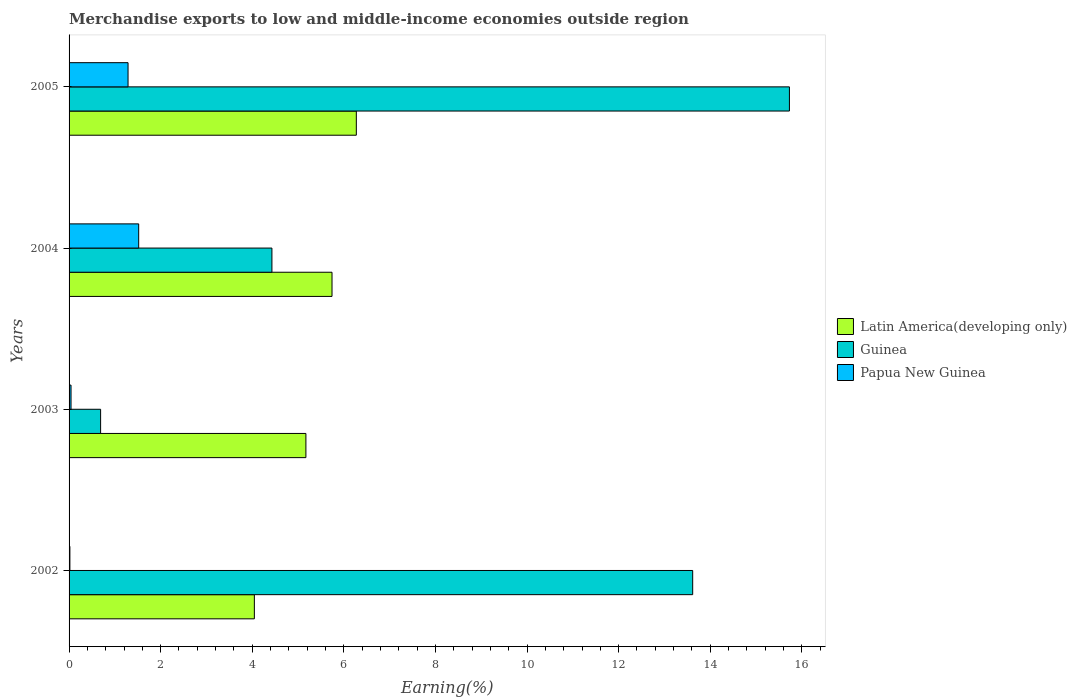How many different coloured bars are there?
Make the answer very short. 3. How many groups of bars are there?
Make the answer very short. 4. Are the number of bars per tick equal to the number of legend labels?
Your response must be concise. Yes. Are the number of bars on each tick of the Y-axis equal?
Your response must be concise. Yes. How many bars are there on the 1st tick from the top?
Your response must be concise. 3. How many bars are there on the 2nd tick from the bottom?
Provide a succinct answer. 3. What is the label of the 1st group of bars from the top?
Provide a short and direct response. 2005. In how many cases, is the number of bars for a given year not equal to the number of legend labels?
Your response must be concise. 0. What is the percentage of amount earned from merchandise exports in Guinea in 2002?
Provide a short and direct response. 13.62. Across all years, what is the maximum percentage of amount earned from merchandise exports in Papua New Guinea?
Keep it short and to the point. 1.52. Across all years, what is the minimum percentage of amount earned from merchandise exports in Latin America(developing only)?
Your answer should be compact. 4.05. In which year was the percentage of amount earned from merchandise exports in Latin America(developing only) minimum?
Make the answer very short. 2002. What is the total percentage of amount earned from merchandise exports in Guinea in the graph?
Provide a succinct answer. 34.46. What is the difference between the percentage of amount earned from merchandise exports in Guinea in 2002 and that in 2003?
Ensure brevity in your answer.  12.93. What is the difference between the percentage of amount earned from merchandise exports in Latin America(developing only) in 2004 and the percentage of amount earned from merchandise exports in Guinea in 2002?
Keep it short and to the point. -7.88. What is the average percentage of amount earned from merchandise exports in Papua New Guinea per year?
Make the answer very short. 0.72. In the year 2002, what is the difference between the percentage of amount earned from merchandise exports in Guinea and percentage of amount earned from merchandise exports in Latin America(developing only)?
Ensure brevity in your answer.  9.57. What is the ratio of the percentage of amount earned from merchandise exports in Latin America(developing only) in 2004 to that in 2005?
Offer a terse response. 0.92. Is the percentage of amount earned from merchandise exports in Guinea in 2003 less than that in 2005?
Give a very brief answer. Yes. What is the difference between the highest and the second highest percentage of amount earned from merchandise exports in Latin America(developing only)?
Offer a terse response. 0.53. What is the difference between the highest and the lowest percentage of amount earned from merchandise exports in Guinea?
Keep it short and to the point. 15.04. In how many years, is the percentage of amount earned from merchandise exports in Latin America(developing only) greater than the average percentage of amount earned from merchandise exports in Latin America(developing only) taken over all years?
Offer a terse response. 2. Is the sum of the percentage of amount earned from merchandise exports in Guinea in 2004 and 2005 greater than the maximum percentage of amount earned from merchandise exports in Latin America(developing only) across all years?
Keep it short and to the point. Yes. What does the 2nd bar from the top in 2004 represents?
Your response must be concise. Guinea. What does the 3rd bar from the bottom in 2004 represents?
Provide a short and direct response. Papua New Guinea. How many bars are there?
Your answer should be compact. 12. How are the legend labels stacked?
Ensure brevity in your answer.  Vertical. What is the title of the graph?
Your response must be concise. Merchandise exports to low and middle-income economies outside region. What is the label or title of the X-axis?
Give a very brief answer. Earning(%). What is the label or title of the Y-axis?
Your answer should be compact. Years. What is the Earning(%) in Latin America(developing only) in 2002?
Give a very brief answer. 4.05. What is the Earning(%) in Guinea in 2002?
Offer a terse response. 13.62. What is the Earning(%) in Papua New Guinea in 2002?
Ensure brevity in your answer.  0.02. What is the Earning(%) of Latin America(developing only) in 2003?
Make the answer very short. 5.17. What is the Earning(%) in Guinea in 2003?
Provide a short and direct response. 0.69. What is the Earning(%) in Papua New Guinea in 2003?
Offer a terse response. 0.04. What is the Earning(%) of Latin America(developing only) in 2004?
Offer a very short reply. 5.74. What is the Earning(%) in Guinea in 2004?
Keep it short and to the point. 4.43. What is the Earning(%) of Papua New Guinea in 2004?
Make the answer very short. 1.52. What is the Earning(%) of Latin America(developing only) in 2005?
Your answer should be compact. 6.27. What is the Earning(%) in Guinea in 2005?
Provide a succinct answer. 15.73. What is the Earning(%) in Papua New Guinea in 2005?
Provide a short and direct response. 1.29. Across all years, what is the maximum Earning(%) of Latin America(developing only)?
Provide a short and direct response. 6.27. Across all years, what is the maximum Earning(%) of Guinea?
Provide a short and direct response. 15.73. Across all years, what is the maximum Earning(%) of Papua New Guinea?
Offer a very short reply. 1.52. Across all years, what is the minimum Earning(%) in Latin America(developing only)?
Your answer should be compact. 4.05. Across all years, what is the minimum Earning(%) of Guinea?
Your answer should be compact. 0.69. Across all years, what is the minimum Earning(%) in Papua New Guinea?
Make the answer very short. 0.02. What is the total Earning(%) in Latin America(developing only) in the graph?
Make the answer very short. 21.23. What is the total Earning(%) of Guinea in the graph?
Keep it short and to the point. 34.46. What is the total Earning(%) of Papua New Guinea in the graph?
Your answer should be very brief. 2.87. What is the difference between the Earning(%) of Latin America(developing only) in 2002 and that in 2003?
Your answer should be very brief. -1.13. What is the difference between the Earning(%) in Guinea in 2002 and that in 2003?
Ensure brevity in your answer.  12.93. What is the difference between the Earning(%) of Papua New Guinea in 2002 and that in 2003?
Provide a succinct answer. -0.02. What is the difference between the Earning(%) in Latin America(developing only) in 2002 and that in 2004?
Provide a short and direct response. -1.7. What is the difference between the Earning(%) of Guinea in 2002 and that in 2004?
Keep it short and to the point. 9.19. What is the difference between the Earning(%) in Papua New Guinea in 2002 and that in 2004?
Provide a short and direct response. -1.5. What is the difference between the Earning(%) in Latin America(developing only) in 2002 and that in 2005?
Ensure brevity in your answer.  -2.23. What is the difference between the Earning(%) in Guinea in 2002 and that in 2005?
Offer a very short reply. -2.11. What is the difference between the Earning(%) of Papua New Guinea in 2002 and that in 2005?
Offer a very short reply. -1.27. What is the difference between the Earning(%) of Latin America(developing only) in 2003 and that in 2004?
Give a very brief answer. -0.57. What is the difference between the Earning(%) in Guinea in 2003 and that in 2004?
Provide a short and direct response. -3.74. What is the difference between the Earning(%) in Papua New Guinea in 2003 and that in 2004?
Give a very brief answer. -1.48. What is the difference between the Earning(%) of Latin America(developing only) in 2003 and that in 2005?
Make the answer very short. -1.1. What is the difference between the Earning(%) of Guinea in 2003 and that in 2005?
Provide a short and direct response. -15.04. What is the difference between the Earning(%) in Papua New Guinea in 2003 and that in 2005?
Your answer should be very brief. -1.25. What is the difference between the Earning(%) in Latin America(developing only) in 2004 and that in 2005?
Provide a succinct answer. -0.53. What is the difference between the Earning(%) in Guinea in 2004 and that in 2005?
Ensure brevity in your answer.  -11.3. What is the difference between the Earning(%) of Papua New Guinea in 2004 and that in 2005?
Give a very brief answer. 0.23. What is the difference between the Earning(%) in Latin America(developing only) in 2002 and the Earning(%) in Guinea in 2003?
Keep it short and to the point. 3.36. What is the difference between the Earning(%) in Latin America(developing only) in 2002 and the Earning(%) in Papua New Guinea in 2003?
Ensure brevity in your answer.  4. What is the difference between the Earning(%) in Guinea in 2002 and the Earning(%) in Papua New Guinea in 2003?
Provide a succinct answer. 13.57. What is the difference between the Earning(%) of Latin America(developing only) in 2002 and the Earning(%) of Guinea in 2004?
Provide a succinct answer. -0.38. What is the difference between the Earning(%) in Latin America(developing only) in 2002 and the Earning(%) in Papua New Guinea in 2004?
Your answer should be very brief. 2.53. What is the difference between the Earning(%) of Guinea in 2002 and the Earning(%) of Papua New Guinea in 2004?
Offer a terse response. 12.1. What is the difference between the Earning(%) of Latin America(developing only) in 2002 and the Earning(%) of Guinea in 2005?
Offer a very short reply. -11.68. What is the difference between the Earning(%) in Latin America(developing only) in 2002 and the Earning(%) in Papua New Guinea in 2005?
Offer a terse response. 2.76. What is the difference between the Earning(%) of Guinea in 2002 and the Earning(%) of Papua New Guinea in 2005?
Offer a very short reply. 12.33. What is the difference between the Earning(%) of Latin America(developing only) in 2003 and the Earning(%) of Guinea in 2004?
Keep it short and to the point. 0.74. What is the difference between the Earning(%) of Latin America(developing only) in 2003 and the Earning(%) of Papua New Guinea in 2004?
Ensure brevity in your answer.  3.65. What is the difference between the Earning(%) in Guinea in 2003 and the Earning(%) in Papua New Guinea in 2004?
Give a very brief answer. -0.83. What is the difference between the Earning(%) of Latin America(developing only) in 2003 and the Earning(%) of Guinea in 2005?
Your answer should be compact. -10.56. What is the difference between the Earning(%) in Latin America(developing only) in 2003 and the Earning(%) in Papua New Guinea in 2005?
Make the answer very short. 3.88. What is the difference between the Earning(%) of Guinea in 2003 and the Earning(%) of Papua New Guinea in 2005?
Your response must be concise. -0.6. What is the difference between the Earning(%) in Latin America(developing only) in 2004 and the Earning(%) in Guinea in 2005?
Ensure brevity in your answer.  -9.99. What is the difference between the Earning(%) in Latin America(developing only) in 2004 and the Earning(%) in Papua New Guinea in 2005?
Ensure brevity in your answer.  4.45. What is the difference between the Earning(%) in Guinea in 2004 and the Earning(%) in Papua New Guinea in 2005?
Provide a short and direct response. 3.14. What is the average Earning(%) in Latin America(developing only) per year?
Keep it short and to the point. 5.31. What is the average Earning(%) in Guinea per year?
Your response must be concise. 8.62. What is the average Earning(%) of Papua New Guinea per year?
Your answer should be very brief. 0.72. In the year 2002, what is the difference between the Earning(%) of Latin America(developing only) and Earning(%) of Guinea?
Your answer should be compact. -9.57. In the year 2002, what is the difference between the Earning(%) of Latin America(developing only) and Earning(%) of Papua New Guinea?
Offer a terse response. 4.03. In the year 2002, what is the difference between the Earning(%) of Guinea and Earning(%) of Papua New Guinea?
Your answer should be compact. 13.6. In the year 2003, what is the difference between the Earning(%) of Latin America(developing only) and Earning(%) of Guinea?
Make the answer very short. 4.48. In the year 2003, what is the difference between the Earning(%) in Latin America(developing only) and Earning(%) in Papua New Guinea?
Keep it short and to the point. 5.13. In the year 2003, what is the difference between the Earning(%) of Guinea and Earning(%) of Papua New Guinea?
Your response must be concise. 0.65. In the year 2004, what is the difference between the Earning(%) in Latin America(developing only) and Earning(%) in Guinea?
Your answer should be compact. 1.31. In the year 2004, what is the difference between the Earning(%) of Latin America(developing only) and Earning(%) of Papua New Guinea?
Your response must be concise. 4.22. In the year 2004, what is the difference between the Earning(%) of Guinea and Earning(%) of Papua New Guinea?
Ensure brevity in your answer.  2.91. In the year 2005, what is the difference between the Earning(%) in Latin America(developing only) and Earning(%) in Guinea?
Provide a succinct answer. -9.46. In the year 2005, what is the difference between the Earning(%) of Latin America(developing only) and Earning(%) of Papua New Guinea?
Offer a terse response. 4.98. In the year 2005, what is the difference between the Earning(%) of Guinea and Earning(%) of Papua New Guinea?
Ensure brevity in your answer.  14.44. What is the ratio of the Earning(%) of Latin America(developing only) in 2002 to that in 2003?
Give a very brief answer. 0.78. What is the ratio of the Earning(%) of Guinea in 2002 to that in 2003?
Give a very brief answer. 19.77. What is the ratio of the Earning(%) of Papua New Guinea in 2002 to that in 2003?
Provide a short and direct response. 0.42. What is the ratio of the Earning(%) in Latin America(developing only) in 2002 to that in 2004?
Your answer should be compact. 0.7. What is the ratio of the Earning(%) of Guinea in 2002 to that in 2004?
Keep it short and to the point. 3.07. What is the ratio of the Earning(%) of Papua New Guinea in 2002 to that in 2004?
Ensure brevity in your answer.  0.01. What is the ratio of the Earning(%) of Latin America(developing only) in 2002 to that in 2005?
Provide a short and direct response. 0.65. What is the ratio of the Earning(%) of Guinea in 2002 to that in 2005?
Give a very brief answer. 0.87. What is the ratio of the Earning(%) in Papua New Guinea in 2002 to that in 2005?
Make the answer very short. 0.01. What is the ratio of the Earning(%) in Latin America(developing only) in 2003 to that in 2004?
Your answer should be compact. 0.9. What is the ratio of the Earning(%) in Guinea in 2003 to that in 2004?
Offer a very short reply. 0.16. What is the ratio of the Earning(%) in Papua New Guinea in 2003 to that in 2004?
Offer a very short reply. 0.03. What is the ratio of the Earning(%) in Latin America(developing only) in 2003 to that in 2005?
Your answer should be very brief. 0.82. What is the ratio of the Earning(%) of Guinea in 2003 to that in 2005?
Provide a succinct answer. 0.04. What is the ratio of the Earning(%) in Papua New Guinea in 2003 to that in 2005?
Ensure brevity in your answer.  0.03. What is the ratio of the Earning(%) in Latin America(developing only) in 2004 to that in 2005?
Provide a short and direct response. 0.92. What is the ratio of the Earning(%) in Guinea in 2004 to that in 2005?
Offer a very short reply. 0.28. What is the ratio of the Earning(%) in Papua New Guinea in 2004 to that in 2005?
Make the answer very short. 1.18. What is the difference between the highest and the second highest Earning(%) of Latin America(developing only)?
Offer a very short reply. 0.53. What is the difference between the highest and the second highest Earning(%) of Guinea?
Ensure brevity in your answer.  2.11. What is the difference between the highest and the second highest Earning(%) of Papua New Guinea?
Your response must be concise. 0.23. What is the difference between the highest and the lowest Earning(%) of Latin America(developing only)?
Give a very brief answer. 2.23. What is the difference between the highest and the lowest Earning(%) in Guinea?
Your response must be concise. 15.04. What is the difference between the highest and the lowest Earning(%) of Papua New Guinea?
Provide a succinct answer. 1.5. 